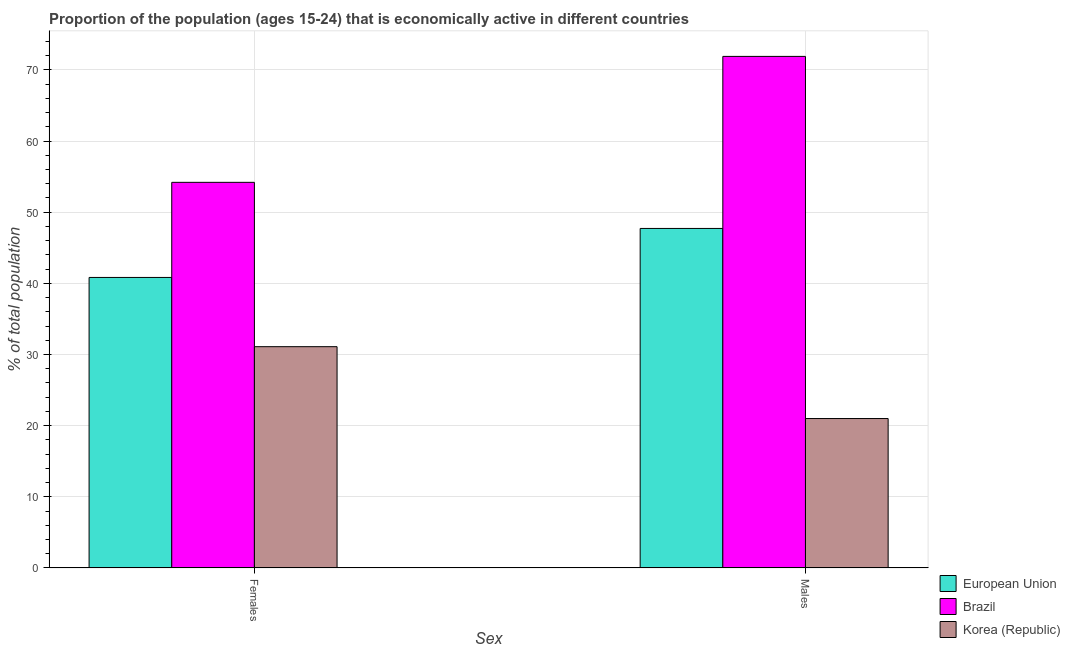Are the number of bars per tick equal to the number of legend labels?
Offer a very short reply. Yes. What is the label of the 2nd group of bars from the left?
Provide a succinct answer. Males. What is the percentage of economically active female population in Korea (Republic)?
Your answer should be compact. 31.1. Across all countries, what is the maximum percentage of economically active female population?
Provide a short and direct response. 54.2. Across all countries, what is the minimum percentage of economically active female population?
Ensure brevity in your answer.  31.1. In which country was the percentage of economically active female population minimum?
Keep it short and to the point. Korea (Republic). What is the total percentage of economically active male population in the graph?
Your answer should be compact. 140.62. What is the difference between the percentage of economically active male population in Brazil and that in European Union?
Offer a terse response. 24.18. What is the difference between the percentage of economically active female population in Brazil and the percentage of economically active male population in Korea (Republic)?
Your answer should be compact. 33.2. What is the average percentage of economically active female population per country?
Provide a short and direct response. 42.04. What is the difference between the percentage of economically active female population and percentage of economically active male population in Korea (Republic)?
Offer a terse response. 10.1. What is the ratio of the percentage of economically active male population in Brazil to that in Korea (Republic)?
Ensure brevity in your answer.  3.42. Is the percentage of economically active female population in Korea (Republic) less than that in European Union?
Ensure brevity in your answer.  Yes. How many bars are there?
Provide a succinct answer. 6. Are the values on the major ticks of Y-axis written in scientific E-notation?
Make the answer very short. No. Does the graph contain any zero values?
Offer a very short reply. No. Where does the legend appear in the graph?
Make the answer very short. Bottom right. How many legend labels are there?
Your response must be concise. 3. How are the legend labels stacked?
Your answer should be very brief. Vertical. What is the title of the graph?
Ensure brevity in your answer.  Proportion of the population (ages 15-24) that is economically active in different countries. What is the label or title of the X-axis?
Provide a succinct answer. Sex. What is the label or title of the Y-axis?
Ensure brevity in your answer.  % of total population. What is the % of total population of European Union in Females?
Keep it short and to the point. 40.83. What is the % of total population of Brazil in Females?
Your answer should be very brief. 54.2. What is the % of total population in Korea (Republic) in Females?
Offer a terse response. 31.1. What is the % of total population in European Union in Males?
Give a very brief answer. 47.72. What is the % of total population of Brazil in Males?
Provide a short and direct response. 71.9. Across all Sex, what is the maximum % of total population of European Union?
Give a very brief answer. 47.72. Across all Sex, what is the maximum % of total population of Brazil?
Ensure brevity in your answer.  71.9. Across all Sex, what is the maximum % of total population of Korea (Republic)?
Ensure brevity in your answer.  31.1. Across all Sex, what is the minimum % of total population of European Union?
Offer a very short reply. 40.83. Across all Sex, what is the minimum % of total population of Brazil?
Make the answer very short. 54.2. What is the total % of total population of European Union in the graph?
Offer a terse response. 88.55. What is the total % of total population in Brazil in the graph?
Give a very brief answer. 126.1. What is the total % of total population in Korea (Republic) in the graph?
Make the answer very short. 52.1. What is the difference between the % of total population of European Union in Females and that in Males?
Offer a very short reply. -6.89. What is the difference between the % of total population of Brazil in Females and that in Males?
Provide a succinct answer. -17.7. What is the difference between the % of total population of Korea (Republic) in Females and that in Males?
Provide a short and direct response. 10.1. What is the difference between the % of total population in European Union in Females and the % of total population in Brazil in Males?
Ensure brevity in your answer.  -31.07. What is the difference between the % of total population in European Union in Females and the % of total population in Korea (Republic) in Males?
Provide a short and direct response. 19.83. What is the difference between the % of total population in Brazil in Females and the % of total population in Korea (Republic) in Males?
Your answer should be very brief. 33.2. What is the average % of total population of European Union per Sex?
Provide a succinct answer. 44.28. What is the average % of total population in Brazil per Sex?
Provide a succinct answer. 63.05. What is the average % of total population in Korea (Republic) per Sex?
Your response must be concise. 26.05. What is the difference between the % of total population in European Union and % of total population in Brazil in Females?
Offer a terse response. -13.37. What is the difference between the % of total population of European Union and % of total population of Korea (Republic) in Females?
Your answer should be compact. 9.73. What is the difference between the % of total population in Brazil and % of total population in Korea (Republic) in Females?
Your answer should be very brief. 23.1. What is the difference between the % of total population in European Union and % of total population in Brazil in Males?
Offer a very short reply. -24.18. What is the difference between the % of total population of European Union and % of total population of Korea (Republic) in Males?
Provide a short and direct response. 26.72. What is the difference between the % of total population of Brazil and % of total population of Korea (Republic) in Males?
Offer a terse response. 50.9. What is the ratio of the % of total population of European Union in Females to that in Males?
Your answer should be compact. 0.86. What is the ratio of the % of total population of Brazil in Females to that in Males?
Offer a very short reply. 0.75. What is the ratio of the % of total population of Korea (Republic) in Females to that in Males?
Your answer should be very brief. 1.48. What is the difference between the highest and the second highest % of total population in European Union?
Provide a short and direct response. 6.89. What is the difference between the highest and the lowest % of total population in European Union?
Offer a very short reply. 6.89. What is the difference between the highest and the lowest % of total population in Brazil?
Your answer should be compact. 17.7. What is the difference between the highest and the lowest % of total population in Korea (Republic)?
Ensure brevity in your answer.  10.1. 